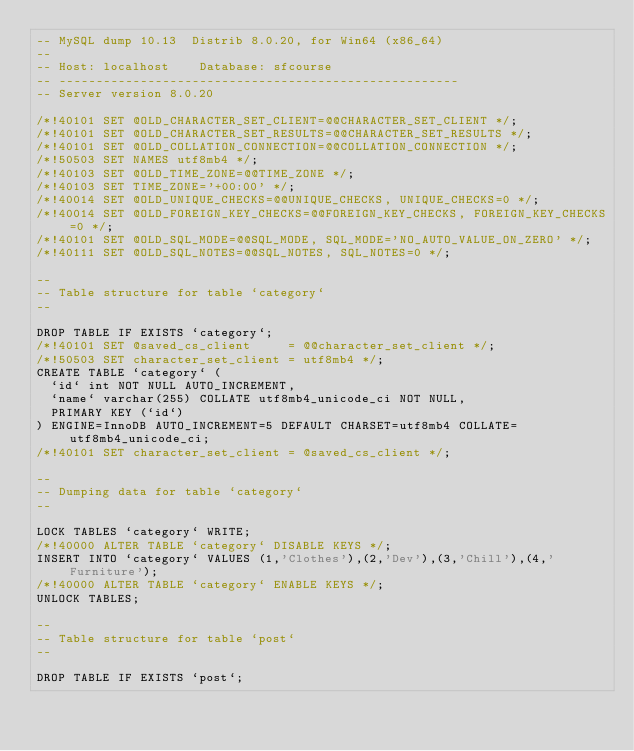<code> <loc_0><loc_0><loc_500><loc_500><_SQL_>-- MySQL dump 10.13  Distrib 8.0.20, for Win64 (x86_64)
--
-- Host: localhost    Database: sfcourse
-- ------------------------------------------------------
-- Server version	8.0.20

/*!40101 SET @OLD_CHARACTER_SET_CLIENT=@@CHARACTER_SET_CLIENT */;
/*!40101 SET @OLD_CHARACTER_SET_RESULTS=@@CHARACTER_SET_RESULTS */;
/*!40101 SET @OLD_COLLATION_CONNECTION=@@COLLATION_CONNECTION */;
/*!50503 SET NAMES utf8mb4 */;
/*!40103 SET @OLD_TIME_ZONE=@@TIME_ZONE */;
/*!40103 SET TIME_ZONE='+00:00' */;
/*!40014 SET @OLD_UNIQUE_CHECKS=@@UNIQUE_CHECKS, UNIQUE_CHECKS=0 */;
/*!40014 SET @OLD_FOREIGN_KEY_CHECKS=@@FOREIGN_KEY_CHECKS, FOREIGN_KEY_CHECKS=0 */;
/*!40101 SET @OLD_SQL_MODE=@@SQL_MODE, SQL_MODE='NO_AUTO_VALUE_ON_ZERO' */;
/*!40111 SET @OLD_SQL_NOTES=@@SQL_NOTES, SQL_NOTES=0 */;

--
-- Table structure for table `category`
--

DROP TABLE IF EXISTS `category`;
/*!40101 SET @saved_cs_client     = @@character_set_client */;
/*!50503 SET character_set_client = utf8mb4 */;
CREATE TABLE `category` (
  `id` int NOT NULL AUTO_INCREMENT,
  `name` varchar(255) COLLATE utf8mb4_unicode_ci NOT NULL,
  PRIMARY KEY (`id`)
) ENGINE=InnoDB AUTO_INCREMENT=5 DEFAULT CHARSET=utf8mb4 COLLATE=utf8mb4_unicode_ci;
/*!40101 SET character_set_client = @saved_cs_client */;

--
-- Dumping data for table `category`
--

LOCK TABLES `category` WRITE;
/*!40000 ALTER TABLE `category` DISABLE KEYS */;
INSERT INTO `category` VALUES (1,'Clothes'),(2,'Dev'),(3,'Chill'),(4,'Furniture');
/*!40000 ALTER TABLE `category` ENABLE KEYS */;
UNLOCK TABLES;

--
-- Table structure for table `post`
--

DROP TABLE IF EXISTS `post`;</code> 